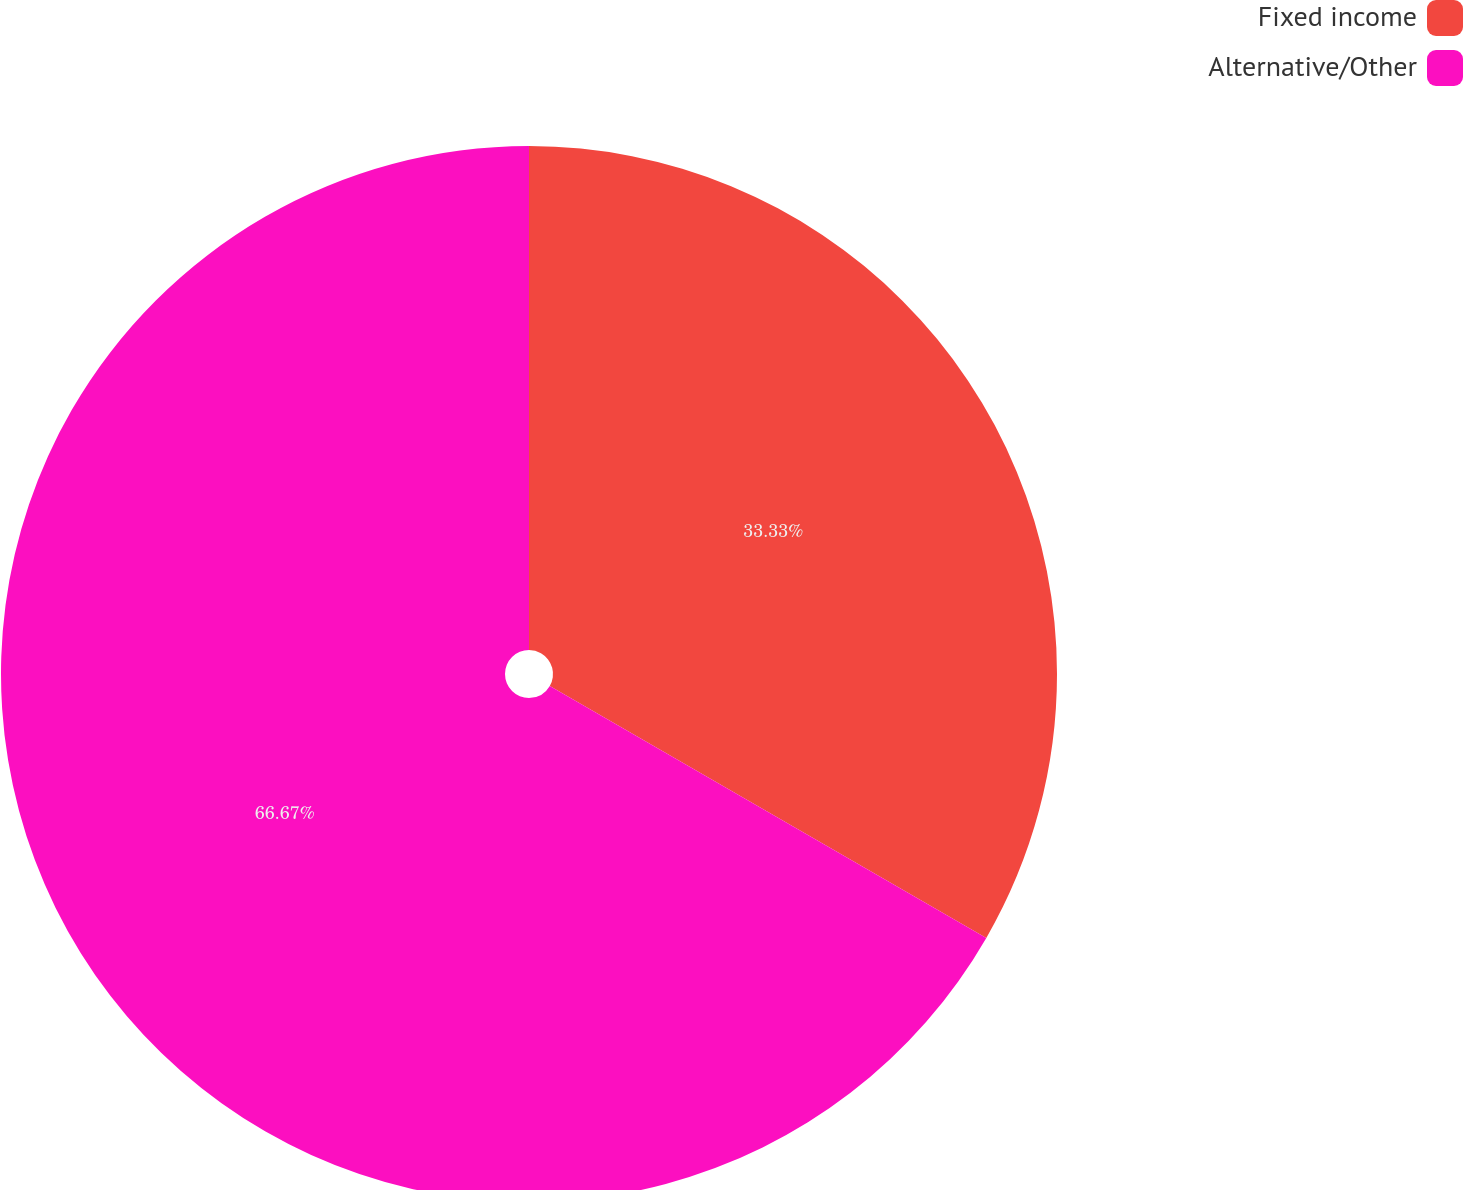Convert chart. <chart><loc_0><loc_0><loc_500><loc_500><pie_chart><fcel>Fixed income<fcel>Alternative/Other<nl><fcel>33.33%<fcel>66.67%<nl></chart> 